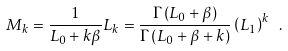Convert formula to latex. <formula><loc_0><loc_0><loc_500><loc_500>M _ { k } = \frac { 1 } { L _ { 0 } + k \beta } L _ { k } = \frac { \Gamma \left ( L _ { 0 } + \beta \right ) } { \Gamma \left ( L _ { 0 } + \beta + k \right ) } \left ( L _ { 1 } \right ) ^ { k } \ .</formula> 